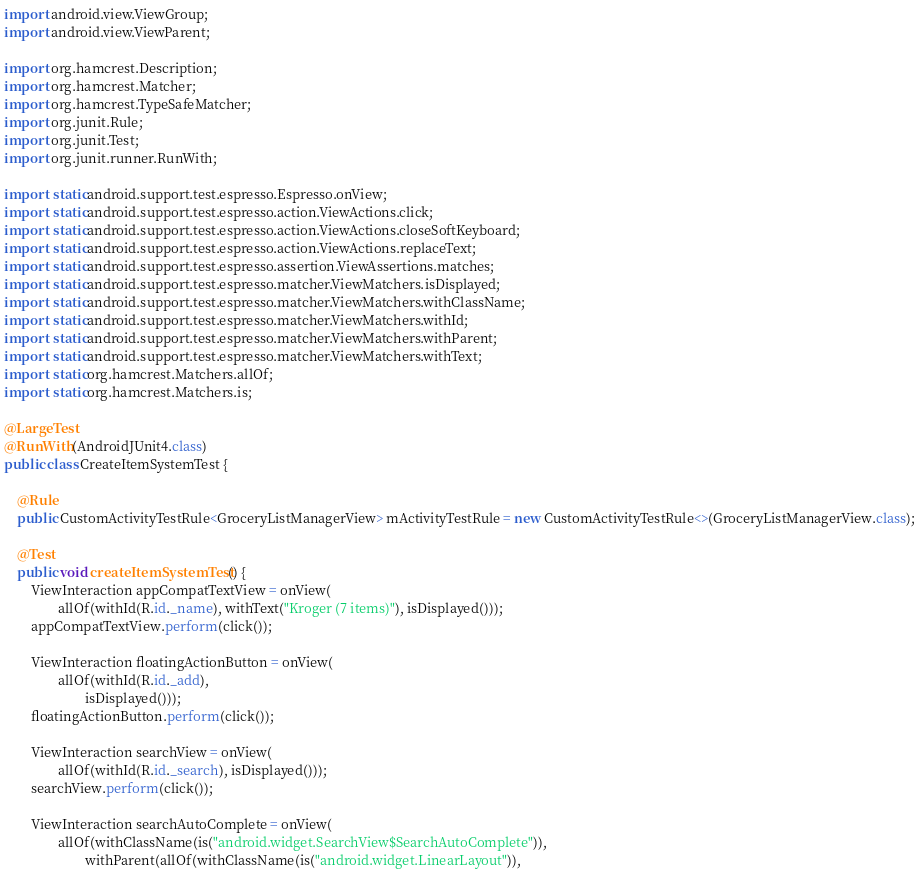<code> <loc_0><loc_0><loc_500><loc_500><_Java_>import android.view.ViewGroup;
import android.view.ViewParent;

import org.hamcrest.Description;
import org.hamcrest.Matcher;
import org.hamcrest.TypeSafeMatcher;
import org.junit.Rule;
import org.junit.Test;
import org.junit.runner.RunWith;

import static android.support.test.espresso.Espresso.onView;
import static android.support.test.espresso.action.ViewActions.click;
import static android.support.test.espresso.action.ViewActions.closeSoftKeyboard;
import static android.support.test.espresso.action.ViewActions.replaceText;
import static android.support.test.espresso.assertion.ViewAssertions.matches;
import static android.support.test.espresso.matcher.ViewMatchers.isDisplayed;
import static android.support.test.espresso.matcher.ViewMatchers.withClassName;
import static android.support.test.espresso.matcher.ViewMatchers.withId;
import static android.support.test.espresso.matcher.ViewMatchers.withParent;
import static android.support.test.espresso.matcher.ViewMatchers.withText;
import static org.hamcrest.Matchers.allOf;
import static org.hamcrest.Matchers.is;

@LargeTest
@RunWith(AndroidJUnit4.class)
public class CreateItemSystemTest {

    @Rule
    public CustomActivityTestRule<GroceryListManagerView> mActivityTestRule = new CustomActivityTestRule<>(GroceryListManagerView.class);

    @Test
    public void createItemSystemTest() {
        ViewInteraction appCompatTextView = onView(
                allOf(withId(R.id._name), withText("Kroger (7 items)"), isDisplayed()));
        appCompatTextView.perform(click());

        ViewInteraction floatingActionButton = onView(
                allOf(withId(R.id._add),
                        isDisplayed()));
        floatingActionButton.perform(click());

        ViewInteraction searchView = onView(
                allOf(withId(R.id._search), isDisplayed()));
        searchView.perform(click());

        ViewInteraction searchAutoComplete = onView(
                allOf(withClassName(is("android.widget.SearchView$SearchAutoComplete")),
                        withParent(allOf(withClassName(is("android.widget.LinearLayout")),</code> 